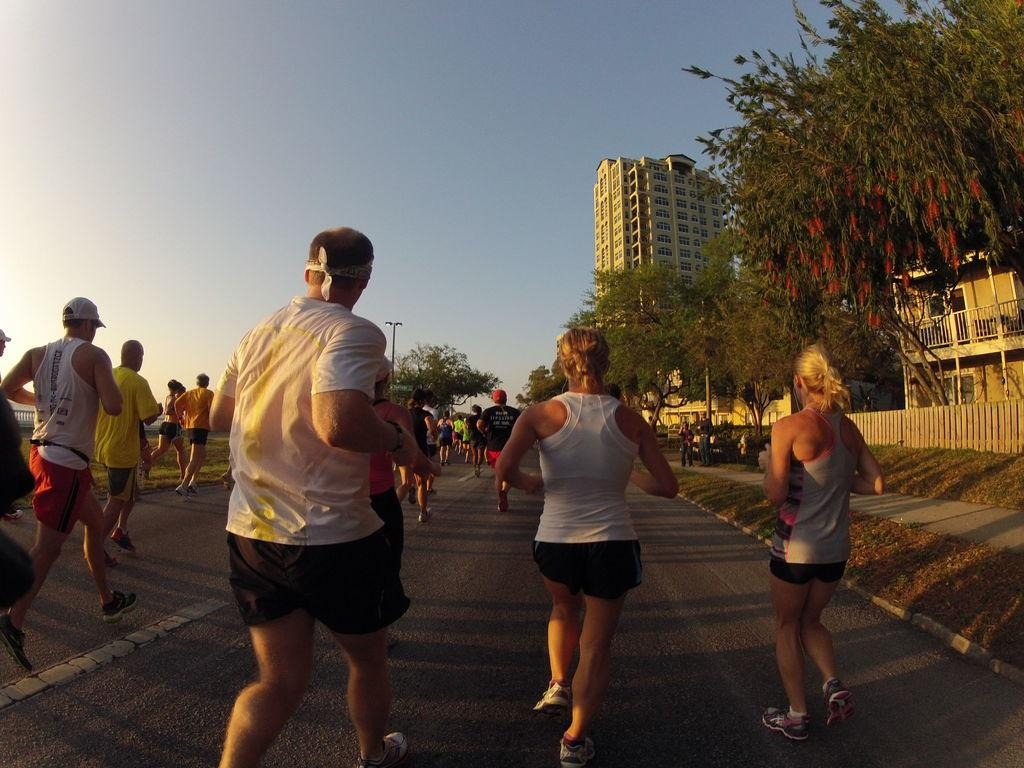How many people are in the image? There is a group of people in the image. What are the people in the image doing? The people are running on the road. What can be seen in the background of the image? There are trees, grass, poles, a house, a building, and the sky visible in the background of the image. What word is being spelled out by the wire in the image? There is no wire present in the image, and therefore no word can be spelled out by it. 